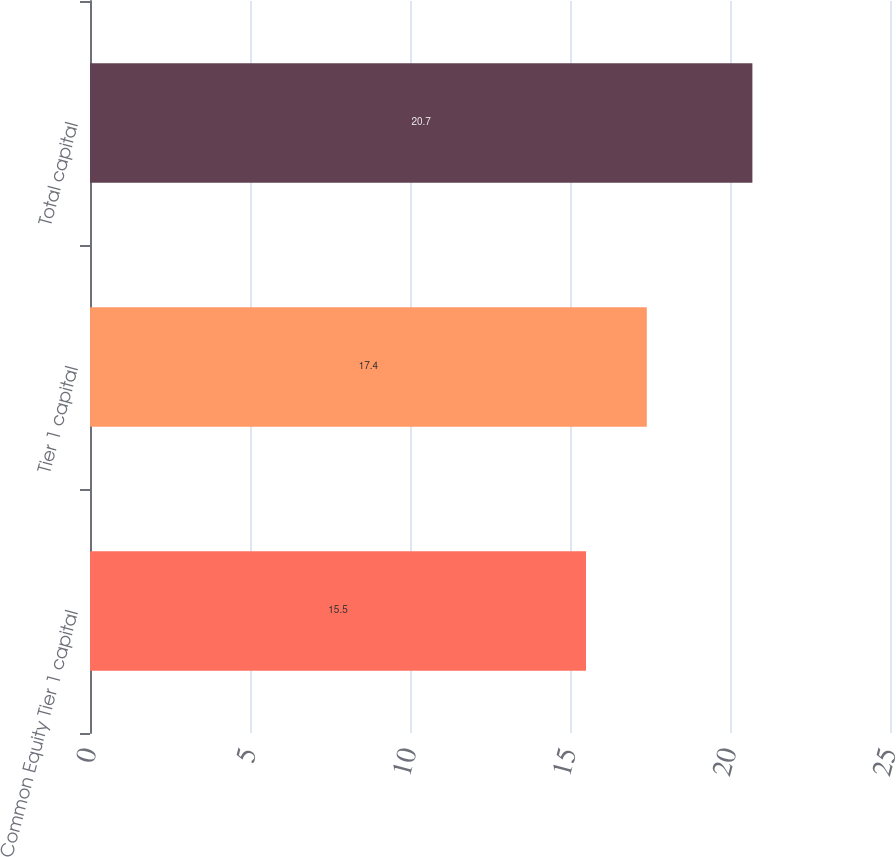Convert chart. <chart><loc_0><loc_0><loc_500><loc_500><bar_chart><fcel>Common Equity Tier 1 capital<fcel>Tier 1 capital<fcel>Total capital<nl><fcel>15.5<fcel>17.4<fcel>20.7<nl></chart> 